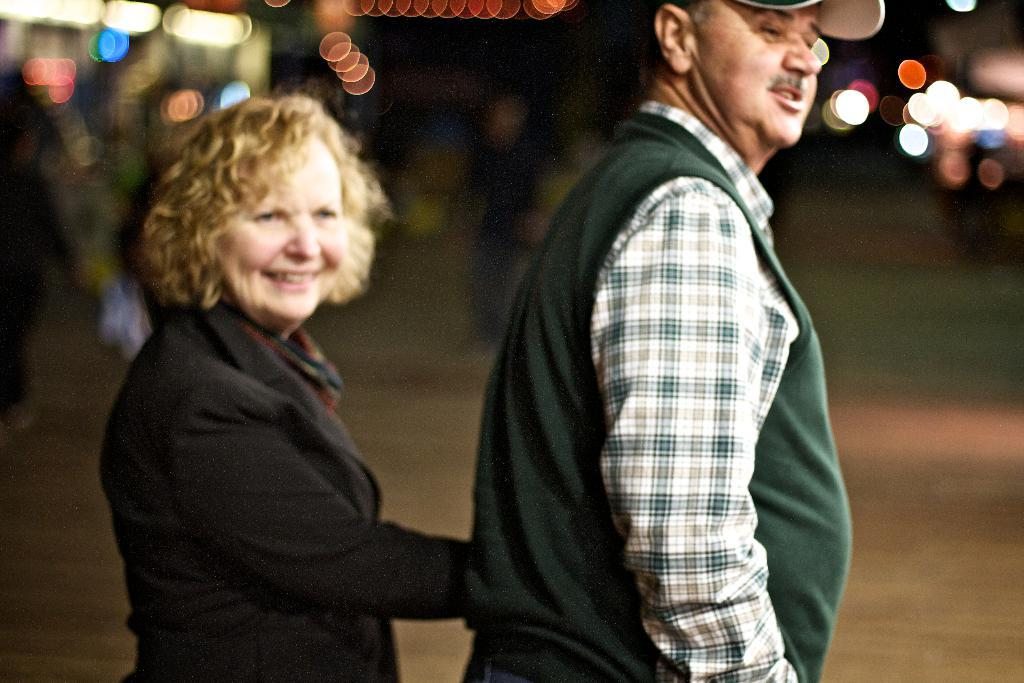How many people are in the image? There are two people in the foreground of the image. What can be seen in the background of the image? The background of the image is blurred. What is at the bottom of the image? There is a road at the bottom of the image. What type of need is being used by the people in the image? There is no mention of a need in the image, so it cannot be determined what type of need might be used. 